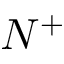<formula> <loc_0><loc_0><loc_500><loc_500>N ^ { + }</formula> 